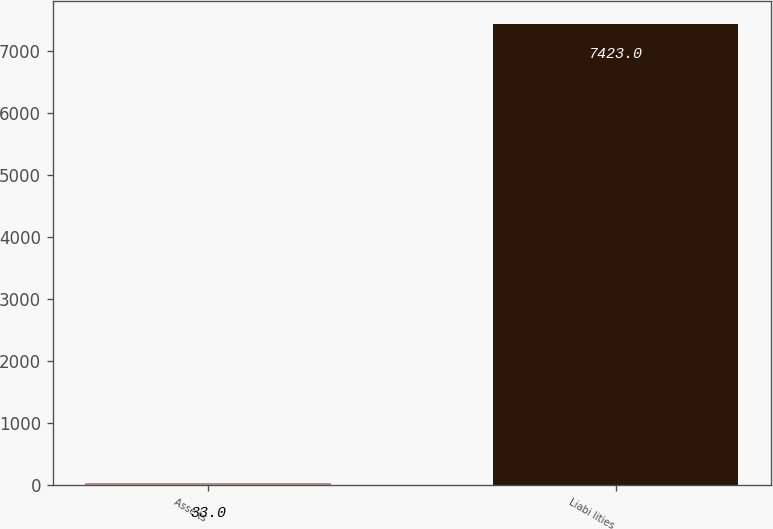Convert chart. <chart><loc_0><loc_0><loc_500><loc_500><bar_chart><fcel>Asse ts<fcel>Liabi lities<nl><fcel>33<fcel>7423<nl></chart> 